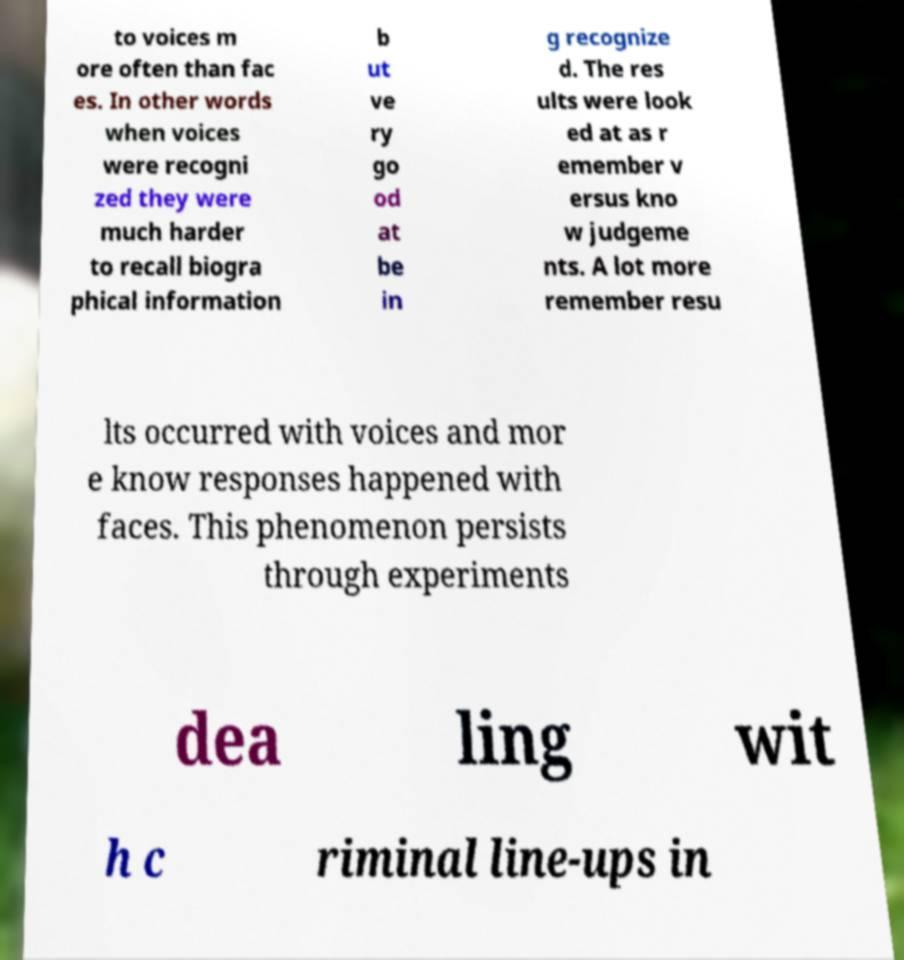What messages or text are displayed in this image? I need them in a readable, typed format. to voices m ore often than fac es. In other words when voices were recogni zed they were much harder to recall biogra phical information b ut ve ry go od at be in g recognize d. The res ults were look ed at as r emember v ersus kno w judgeme nts. A lot more remember resu lts occurred with voices and mor e know responses happened with faces. This phenomenon persists through experiments dea ling wit h c riminal line-ups in 